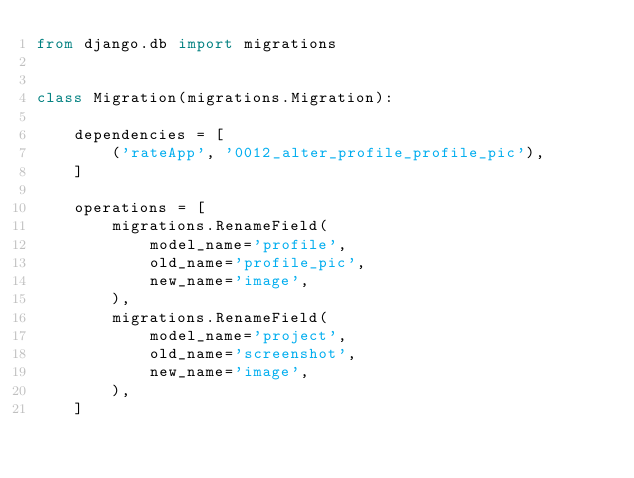Convert code to text. <code><loc_0><loc_0><loc_500><loc_500><_Python_>from django.db import migrations


class Migration(migrations.Migration):

    dependencies = [
        ('rateApp', '0012_alter_profile_profile_pic'),
    ]

    operations = [
        migrations.RenameField(
            model_name='profile',
            old_name='profile_pic',
            new_name='image',
        ),
        migrations.RenameField(
            model_name='project',
            old_name='screenshot',
            new_name='image',
        ),
    ]
</code> 